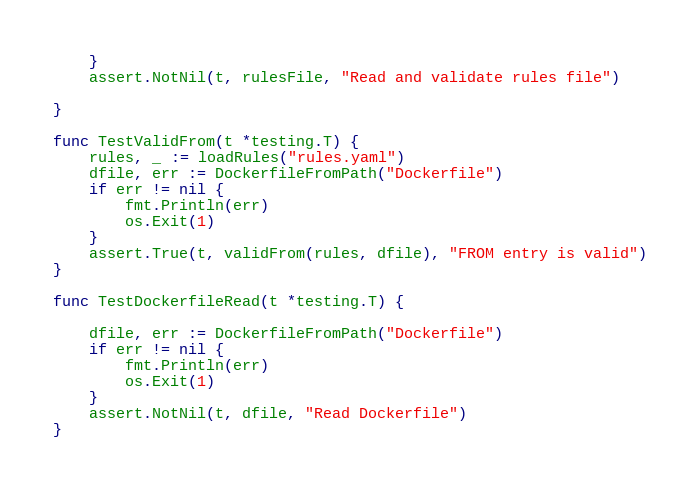<code> <loc_0><loc_0><loc_500><loc_500><_Go_>	}
	assert.NotNil(t, rulesFile, "Read and validate rules file")

}

func TestValidFrom(t *testing.T) {
	rules, _ := loadRules("rules.yaml")
	dfile, err := DockerfileFromPath("Dockerfile")
	if err != nil {
		fmt.Println(err)
		os.Exit(1)
	}
	assert.True(t, validFrom(rules, dfile), "FROM entry is valid")
}

func TestDockerfileRead(t *testing.T) {

	dfile, err := DockerfileFromPath("Dockerfile")
	if err != nil {
		fmt.Println(err)
		os.Exit(1)
	}
	assert.NotNil(t, dfile, "Read Dockerfile")
}
</code> 